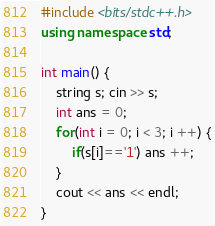<code> <loc_0><loc_0><loc_500><loc_500><_C++_>#include <bits/stdc++.h>
using namespace std;

int main() {
    string s; cin >> s;
    int ans = 0;
    for(int i = 0; i < 3; i ++) {
        if(s[i]=='1') ans ++;
    }
    cout << ans << endl;
}</code> 